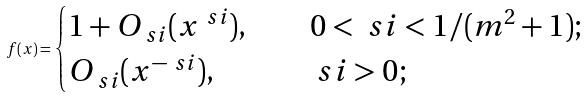Convert formula to latex. <formula><loc_0><loc_0><loc_500><loc_500>f ( x ) = \begin{cases} 1 + O _ { \ s i } ( x ^ { \ s i } ) , & \quad 0 < \ s i < 1 / ( m ^ { 2 } + 1 ) ; \\ O _ { \ s i } ( x ^ { - \ s i } ) , & \quad \ s i > 0 ; \end{cases}</formula> 